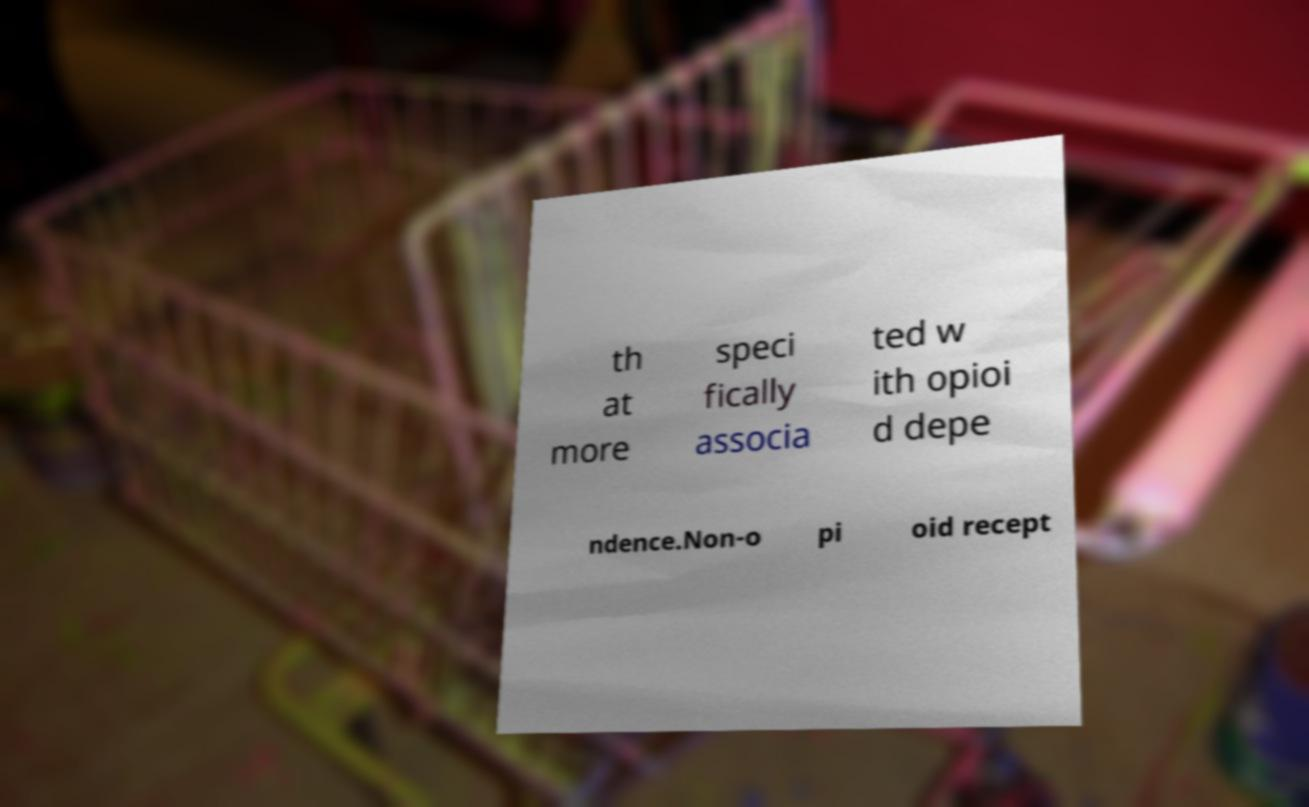Could you extract and type out the text from this image? th at more speci fically associa ted w ith opioi d depe ndence.Non-o pi oid recept 